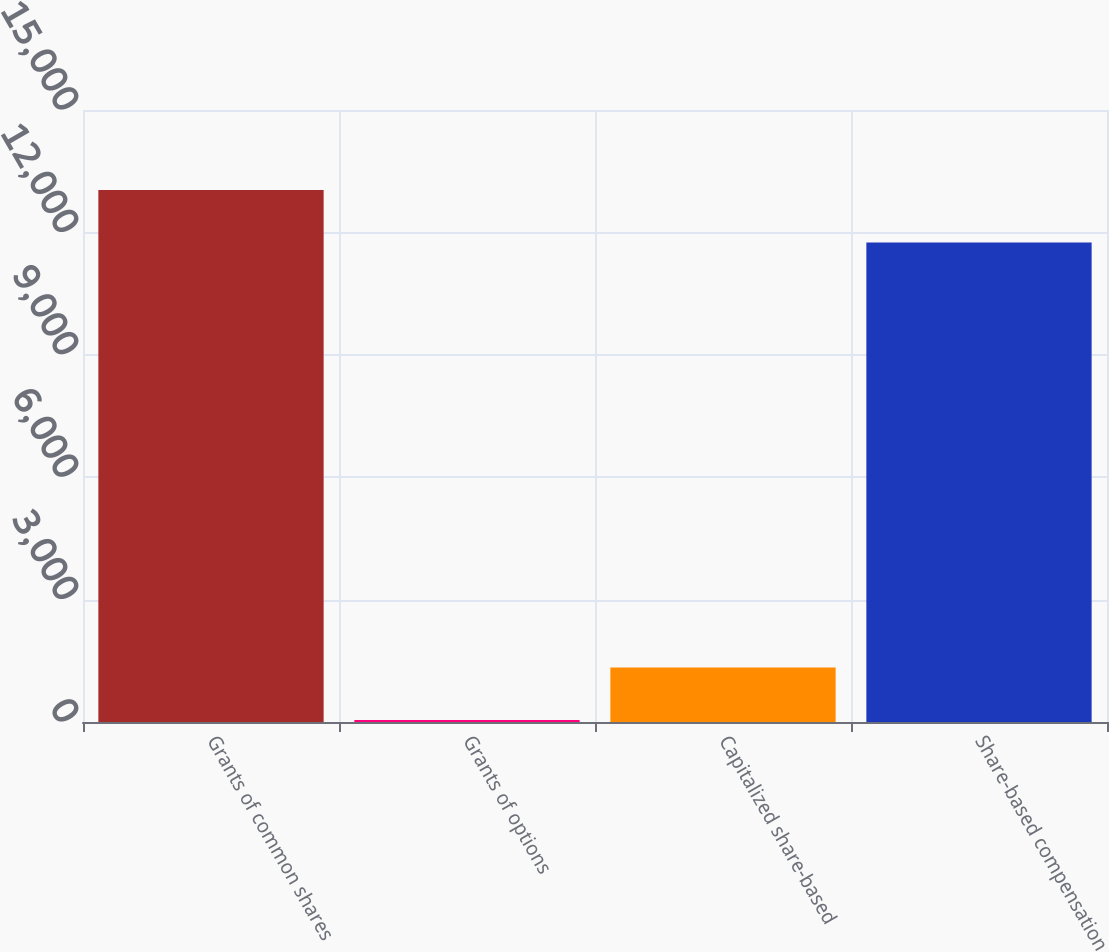Convert chart. <chart><loc_0><loc_0><loc_500><loc_500><bar_chart><fcel>Grants of common shares<fcel>Grants of options<fcel>Capitalized share-based<fcel>Share-based compensation<nl><fcel>13037.3<fcel>49<fcel>1333.3<fcel>11753<nl></chart> 